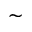<formula> <loc_0><loc_0><loc_500><loc_500>\sim</formula> 